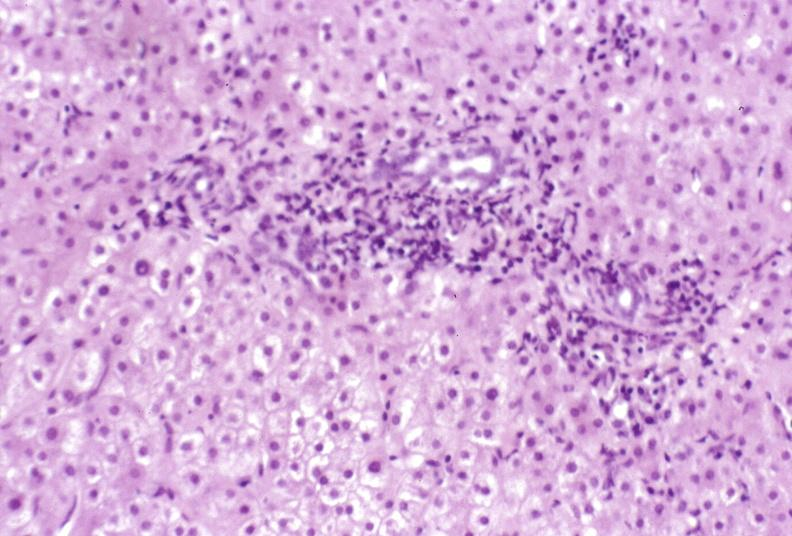does this image show primary biliary cirrhosis?
Answer the question using a single word or phrase. Yes 